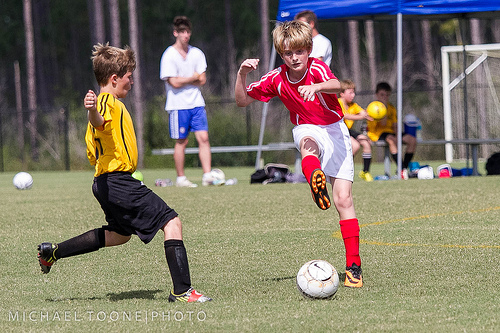<image>
Can you confirm if the ball is on the grass? Yes. Looking at the image, I can see the ball is positioned on top of the grass, with the grass providing support. Is there a ball behind the boy? Yes. From this viewpoint, the ball is positioned behind the boy, with the boy partially or fully occluding the ball. Where is the ball in relation to the boy? Is it behind the boy? No. The ball is not behind the boy. From this viewpoint, the ball appears to be positioned elsewhere in the scene. Is there a ball in front of the boy? Yes. The ball is positioned in front of the boy, appearing closer to the camera viewpoint. 